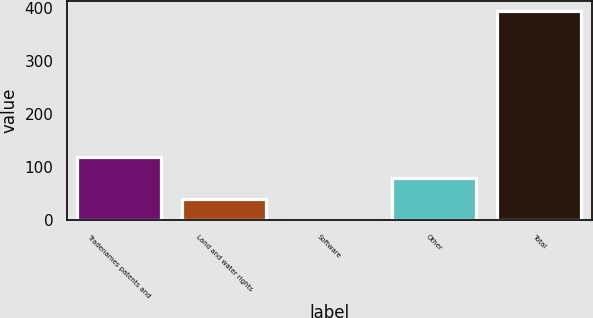Convert chart to OTSL. <chart><loc_0><loc_0><loc_500><loc_500><bar_chart><fcel>Tradenames patents and<fcel>Land and water rights<fcel>Software<fcel>Other<fcel>Total<nl><fcel>118.6<fcel>40.2<fcel>1<fcel>79.4<fcel>393<nl></chart> 